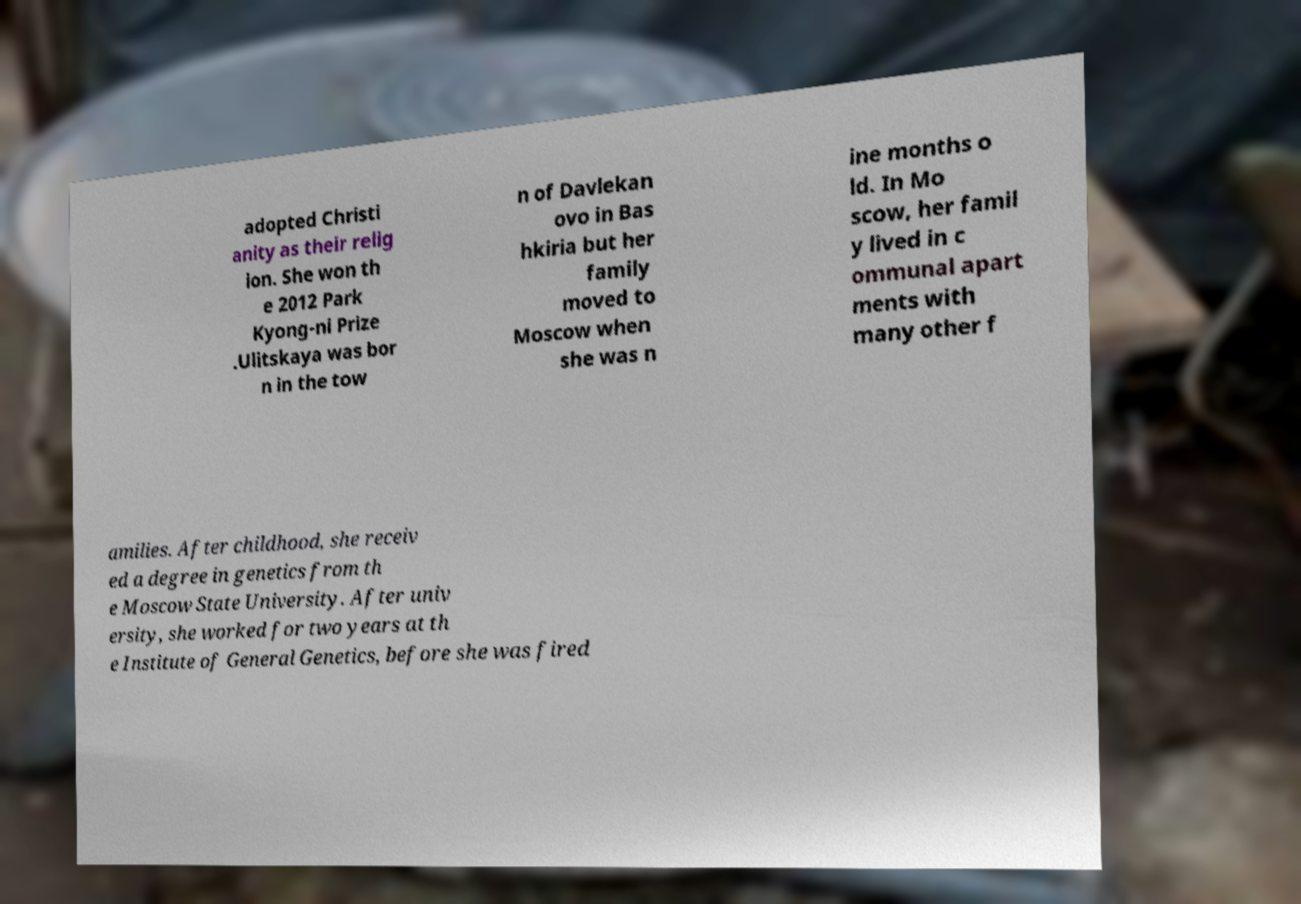Could you assist in decoding the text presented in this image and type it out clearly? adopted Christi anity as their relig ion. She won th e 2012 Park Kyong-ni Prize .Ulitskaya was bor n in the tow n of Davlekan ovo in Bas hkiria but her family moved to Moscow when she was n ine months o ld. In Mo scow, her famil y lived in c ommunal apart ments with many other f amilies. After childhood, she receiv ed a degree in genetics from th e Moscow State University. After univ ersity, she worked for two years at th e Institute of General Genetics, before she was fired 